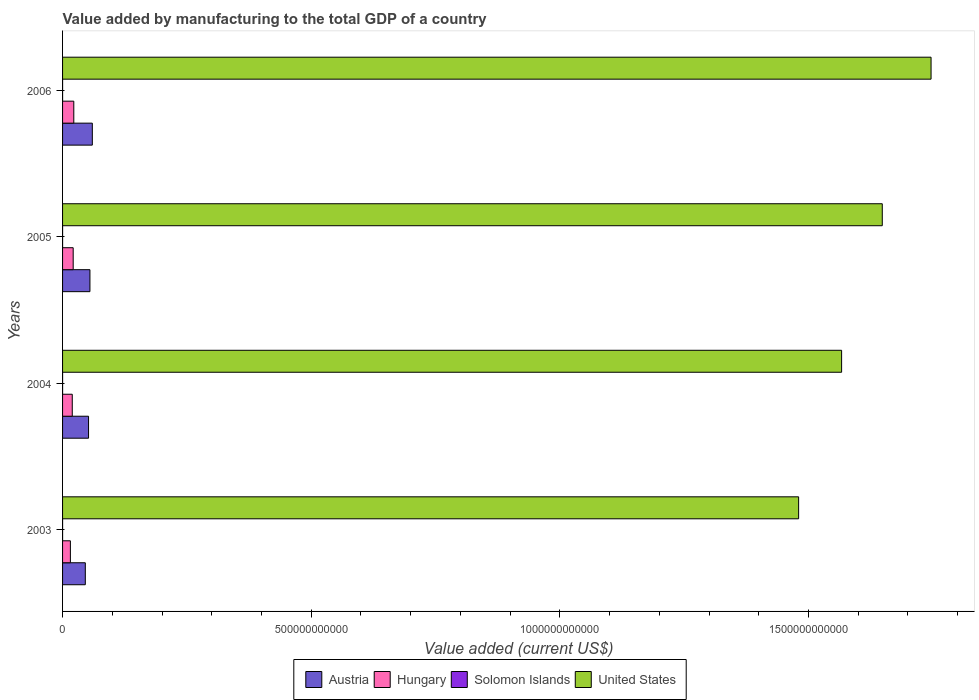How many different coloured bars are there?
Your answer should be very brief. 4. Are the number of bars on each tick of the Y-axis equal?
Offer a very short reply. Yes. How many bars are there on the 2nd tick from the bottom?
Make the answer very short. 4. What is the label of the 3rd group of bars from the top?
Your answer should be compact. 2004. In how many cases, is the number of bars for a given year not equal to the number of legend labels?
Your answer should be compact. 0. What is the value added by manufacturing to the total GDP in Austria in 2004?
Provide a short and direct response. 5.22e+1. Across all years, what is the maximum value added by manufacturing to the total GDP in Hungary?
Ensure brevity in your answer.  2.26e+1. Across all years, what is the minimum value added by manufacturing to the total GDP in Austria?
Your response must be concise. 4.57e+1. In which year was the value added by manufacturing to the total GDP in Hungary maximum?
Your response must be concise. 2006. In which year was the value added by manufacturing to the total GDP in Austria minimum?
Provide a succinct answer. 2003. What is the total value added by manufacturing to the total GDP in Solomon Islands in the graph?
Your answer should be compact. 8.92e+07. What is the difference between the value added by manufacturing to the total GDP in Hungary in 2003 and that in 2005?
Your answer should be compact. -5.61e+09. What is the difference between the value added by manufacturing to the total GDP in Solomon Islands in 2006 and the value added by manufacturing to the total GDP in Austria in 2005?
Offer a terse response. -5.50e+1. What is the average value added by manufacturing to the total GDP in Hungary per year?
Provide a short and direct response. 1.98e+1. In the year 2003, what is the difference between the value added by manufacturing to the total GDP in Hungary and value added by manufacturing to the total GDP in United States?
Keep it short and to the point. -1.46e+12. In how many years, is the value added by manufacturing to the total GDP in Austria greater than 200000000000 US$?
Give a very brief answer. 0. What is the ratio of the value added by manufacturing to the total GDP in United States in 2005 to that in 2006?
Make the answer very short. 0.94. Is the value added by manufacturing to the total GDP in Austria in 2003 less than that in 2006?
Ensure brevity in your answer.  Yes. What is the difference between the highest and the second highest value added by manufacturing to the total GDP in Hungary?
Your answer should be compact. 1.24e+09. What is the difference between the highest and the lowest value added by manufacturing to the total GDP in United States?
Ensure brevity in your answer.  2.66e+11. What does the 2nd bar from the top in 2004 represents?
Provide a succinct answer. Solomon Islands. What does the 2nd bar from the bottom in 2003 represents?
Give a very brief answer. Hungary. Is it the case that in every year, the sum of the value added by manufacturing to the total GDP in Austria and value added by manufacturing to the total GDP in Hungary is greater than the value added by manufacturing to the total GDP in United States?
Your response must be concise. No. What is the difference between two consecutive major ticks on the X-axis?
Keep it short and to the point. 5.00e+11. Does the graph contain grids?
Keep it short and to the point. No. How many legend labels are there?
Ensure brevity in your answer.  4. What is the title of the graph?
Ensure brevity in your answer.  Value added by manufacturing to the total GDP of a country. Does "Croatia" appear as one of the legend labels in the graph?
Make the answer very short. No. What is the label or title of the X-axis?
Provide a succinct answer. Value added (current US$). What is the label or title of the Y-axis?
Provide a succinct answer. Years. What is the Value added (current US$) in Austria in 2003?
Offer a very short reply. 4.57e+1. What is the Value added (current US$) of Hungary in 2003?
Make the answer very short. 1.57e+1. What is the Value added (current US$) in Solomon Islands in 2003?
Give a very brief answer. 2.09e+07. What is the Value added (current US$) of United States in 2003?
Offer a very short reply. 1.48e+12. What is the Value added (current US$) of Austria in 2004?
Your response must be concise. 5.22e+1. What is the Value added (current US$) of Hungary in 2004?
Your answer should be compact. 1.95e+1. What is the Value added (current US$) of Solomon Islands in 2004?
Offer a terse response. 2.35e+07. What is the Value added (current US$) in United States in 2004?
Offer a very short reply. 1.57e+12. What is the Value added (current US$) in Austria in 2005?
Provide a short and direct response. 5.50e+1. What is the Value added (current US$) in Hungary in 2005?
Ensure brevity in your answer.  2.14e+1. What is the Value added (current US$) in Solomon Islands in 2005?
Provide a short and direct response. 2.30e+07. What is the Value added (current US$) in United States in 2005?
Offer a terse response. 1.65e+12. What is the Value added (current US$) of Austria in 2006?
Offer a very short reply. 5.98e+1. What is the Value added (current US$) of Hungary in 2006?
Make the answer very short. 2.26e+1. What is the Value added (current US$) of Solomon Islands in 2006?
Make the answer very short. 2.17e+07. What is the Value added (current US$) of United States in 2006?
Make the answer very short. 1.75e+12. Across all years, what is the maximum Value added (current US$) of Austria?
Provide a short and direct response. 5.98e+1. Across all years, what is the maximum Value added (current US$) of Hungary?
Provide a succinct answer. 2.26e+1. Across all years, what is the maximum Value added (current US$) of Solomon Islands?
Provide a short and direct response. 2.35e+07. Across all years, what is the maximum Value added (current US$) of United States?
Offer a very short reply. 1.75e+12. Across all years, what is the minimum Value added (current US$) of Austria?
Offer a terse response. 4.57e+1. Across all years, what is the minimum Value added (current US$) of Hungary?
Provide a short and direct response. 1.57e+1. Across all years, what is the minimum Value added (current US$) of Solomon Islands?
Your response must be concise. 2.09e+07. Across all years, what is the minimum Value added (current US$) in United States?
Offer a terse response. 1.48e+12. What is the total Value added (current US$) in Austria in the graph?
Provide a succinct answer. 2.13e+11. What is the total Value added (current US$) of Hungary in the graph?
Offer a terse response. 7.92e+1. What is the total Value added (current US$) in Solomon Islands in the graph?
Your answer should be compact. 8.92e+07. What is the total Value added (current US$) in United States in the graph?
Your answer should be compact. 6.44e+12. What is the difference between the Value added (current US$) in Austria in 2003 and that in 2004?
Your answer should be compact. -6.50e+09. What is the difference between the Value added (current US$) of Hungary in 2003 and that in 2004?
Provide a short and direct response. -3.76e+09. What is the difference between the Value added (current US$) in Solomon Islands in 2003 and that in 2004?
Ensure brevity in your answer.  -2.68e+06. What is the difference between the Value added (current US$) in United States in 2003 and that in 2004?
Make the answer very short. -8.64e+1. What is the difference between the Value added (current US$) of Austria in 2003 and that in 2005?
Ensure brevity in your answer.  -9.31e+09. What is the difference between the Value added (current US$) of Hungary in 2003 and that in 2005?
Make the answer very short. -5.61e+09. What is the difference between the Value added (current US$) in Solomon Islands in 2003 and that in 2005?
Your response must be concise. -2.18e+06. What is the difference between the Value added (current US$) of United States in 2003 and that in 2005?
Keep it short and to the point. -1.68e+11. What is the difference between the Value added (current US$) of Austria in 2003 and that in 2006?
Your answer should be compact. -1.41e+1. What is the difference between the Value added (current US$) in Hungary in 2003 and that in 2006?
Ensure brevity in your answer.  -6.85e+09. What is the difference between the Value added (current US$) of Solomon Islands in 2003 and that in 2006?
Your answer should be compact. -8.86e+05. What is the difference between the Value added (current US$) in United States in 2003 and that in 2006?
Your answer should be very brief. -2.66e+11. What is the difference between the Value added (current US$) in Austria in 2004 and that in 2005?
Keep it short and to the point. -2.80e+09. What is the difference between the Value added (current US$) of Hungary in 2004 and that in 2005?
Give a very brief answer. -1.85e+09. What is the difference between the Value added (current US$) of Solomon Islands in 2004 and that in 2005?
Your answer should be very brief. 5.00e+05. What is the difference between the Value added (current US$) of United States in 2004 and that in 2005?
Offer a very short reply. -8.18e+1. What is the difference between the Value added (current US$) in Austria in 2004 and that in 2006?
Your response must be concise. -7.60e+09. What is the difference between the Value added (current US$) of Hungary in 2004 and that in 2006?
Your response must be concise. -3.09e+09. What is the difference between the Value added (current US$) of Solomon Islands in 2004 and that in 2006?
Make the answer very short. 1.79e+06. What is the difference between the Value added (current US$) in United States in 2004 and that in 2006?
Make the answer very short. -1.80e+11. What is the difference between the Value added (current US$) of Austria in 2005 and that in 2006?
Your answer should be very brief. -4.80e+09. What is the difference between the Value added (current US$) in Hungary in 2005 and that in 2006?
Offer a very short reply. -1.24e+09. What is the difference between the Value added (current US$) in Solomon Islands in 2005 and that in 2006?
Offer a terse response. 1.29e+06. What is the difference between the Value added (current US$) in United States in 2005 and that in 2006?
Provide a short and direct response. -9.81e+1. What is the difference between the Value added (current US$) in Austria in 2003 and the Value added (current US$) in Hungary in 2004?
Give a very brief answer. 2.62e+1. What is the difference between the Value added (current US$) of Austria in 2003 and the Value added (current US$) of Solomon Islands in 2004?
Make the answer very short. 4.57e+1. What is the difference between the Value added (current US$) in Austria in 2003 and the Value added (current US$) in United States in 2004?
Provide a short and direct response. -1.52e+12. What is the difference between the Value added (current US$) in Hungary in 2003 and the Value added (current US$) in Solomon Islands in 2004?
Provide a short and direct response. 1.57e+1. What is the difference between the Value added (current US$) of Hungary in 2003 and the Value added (current US$) of United States in 2004?
Provide a succinct answer. -1.55e+12. What is the difference between the Value added (current US$) of Solomon Islands in 2003 and the Value added (current US$) of United States in 2004?
Your answer should be compact. -1.57e+12. What is the difference between the Value added (current US$) in Austria in 2003 and the Value added (current US$) in Hungary in 2005?
Your answer should be very brief. 2.44e+1. What is the difference between the Value added (current US$) of Austria in 2003 and the Value added (current US$) of Solomon Islands in 2005?
Give a very brief answer. 4.57e+1. What is the difference between the Value added (current US$) in Austria in 2003 and the Value added (current US$) in United States in 2005?
Your answer should be very brief. -1.60e+12. What is the difference between the Value added (current US$) in Hungary in 2003 and the Value added (current US$) in Solomon Islands in 2005?
Provide a succinct answer. 1.57e+1. What is the difference between the Value added (current US$) in Hungary in 2003 and the Value added (current US$) in United States in 2005?
Make the answer very short. -1.63e+12. What is the difference between the Value added (current US$) of Solomon Islands in 2003 and the Value added (current US$) of United States in 2005?
Offer a terse response. -1.65e+12. What is the difference between the Value added (current US$) in Austria in 2003 and the Value added (current US$) in Hungary in 2006?
Ensure brevity in your answer.  2.31e+1. What is the difference between the Value added (current US$) in Austria in 2003 and the Value added (current US$) in Solomon Islands in 2006?
Offer a very short reply. 4.57e+1. What is the difference between the Value added (current US$) in Austria in 2003 and the Value added (current US$) in United States in 2006?
Keep it short and to the point. -1.70e+12. What is the difference between the Value added (current US$) in Hungary in 2003 and the Value added (current US$) in Solomon Islands in 2006?
Provide a succinct answer. 1.57e+1. What is the difference between the Value added (current US$) in Hungary in 2003 and the Value added (current US$) in United States in 2006?
Ensure brevity in your answer.  -1.73e+12. What is the difference between the Value added (current US$) of Solomon Islands in 2003 and the Value added (current US$) of United States in 2006?
Keep it short and to the point. -1.75e+12. What is the difference between the Value added (current US$) in Austria in 2004 and the Value added (current US$) in Hungary in 2005?
Provide a succinct answer. 3.09e+1. What is the difference between the Value added (current US$) of Austria in 2004 and the Value added (current US$) of Solomon Islands in 2005?
Offer a very short reply. 5.22e+1. What is the difference between the Value added (current US$) of Austria in 2004 and the Value added (current US$) of United States in 2005?
Offer a very short reply. -1.60e+12. What is the difference between the Value added (current US$) in Hungary in 2004 and the Value added (current US$) in Solomon Islands in 2005?
Offer a terse response. 1.95e+1. What is the difference between the Value added (current US$) of Hungary in 2004 and the Value added (current US$) of United States in 2005?
Provide a succinct answer. -1.63e+12. What is the difference between the Value added (current US$) of Solomon Islands in 2004 and the Value added (current US$) of United States in 2005?
Keep it short and to the point. -1.65e+12. What is the difference between the Value added (current US$) in Austria in 2004 and the Value added (current US$) in Hungary in 2006?
Make the answer very short. 2.96e+1. What is the difference between the Value added (current US$) in Austria in 2004 and the Value added (current US$) in Solomon Islands in 2006?
Your response must be concise. 5.22e+1. What is the difference between the Value added (current US$) in Austria in 2004 and the Value added (current US$) in United States in 2006?
Offer a terse response. -1.69e+12. What is the difference between the Value added (current US$) of Hungary in 2004 and the Value added (current US$) of Solomon Islands in 2006?
Ensure brevity in your answer.  1.95e+1. What is the difference between the Value added (current US$) in Hungary in 2004 and the Value added (current US$) in United States in 2006?
Provide a succinct answer. -1.73e+12. What is the difference between the Value added (current US$) of Solomon Islands in 2004 and the Value added (current US$) of United States in 2006?
Provide a succinct answer. -1.75e+12. What is the difference between the Value added (current US$) of Austria in 2005 and the Value added (current US$) of Hungary in 2006?
Keep it short and to the point. 3.24e+1. What is the difference between the Value added (current US$) in Austria in 2005 and the Value added (current US$) in Solomon Islands in 2006?
Offer a terse response. 5.50e+1. What is the difference between the Value added (current US$) in Austria in 2005 and the Value added (current US$) in United States in 2006?
Ensure brevity in your answer.  -1.69e+12. What is the difference between the Value added (current US$) in Hungary in 2005 and the Value added (current US$) in Solomon Islands in 2006?
Give a very brief answer. 2.13e+1. What is the difference between the Value added (current US$) in Hungary in 2005 and the Value added (current US$) in United States in 2006?
Your answer should be compact. -1.73e+12. What is the difference between the Value added (current US$) of Solomon Islands in 2005 and the Value added (current US$) of United States in 2006?
Make the answer very short. -1.75e+12. What is the average Value added (current US$) of Austria per year?
Keep it short and to the point. 5.32e+1. What is the average Value added (current US$) of Hungary per year?
Give a very brief answer. 1.98e+1. What is the average Value added (current US$) in Solomon Islands per year?
Keep it short and to the point. 2.23e+07. What is the average Value added (current US$) of United States per year?
Give a very brief answer. 1.61e+12. In the year 2003, what is the difference between the Value added (current US$) of Austria and Value added (current US$) of Hungary?
Make the answer very short. 3.00e+1. In the year 2003, what is the difference between the Value added (current US$) in Austria and Value added (current US$) in Solomon Islands?
Give a very brief answer. 4.57e+1. In the year 2003, what is the difference between the Value added (current US$) in Austria and Value added (current US$) in United States?
Offer a terse response. -1.43e+12. In the year 2003, what is the difference between the Value added (current US$) in Hungary and Value added (current US$) in Solomon Islands?
Provide a succinct answer. 1.57e+1. In the year 2003, what is the difference between the Value added (current US$) in Hungary and Value added (current US$) in United States?
Your response must be concise. -1.46e+12. In the year 2003, what is the difference between the Value added (current US$) of Solomon Islands and Value added (current US$) of United States?
Offer a terse response. -1.48e+12. In the year 2004, what is the difference between the Value added (current US$) in Austria and Value added (current US$) in Hungary?
Provide a succinct answer. 3.27e+1. In the year 2004, what is the difference between the Value added (current US$) of Austria and Value added (current US$) of Solomon Islands?
Provide a short and direct response. 5.22e+1. In the year 2004, what is the difference between the Value added (current US$) of Austria and Value added (current US$) of United States?
Offer a terse response. -1.51e+12. In the year 2004, what is the difference between the Value added (current US$) of Hungary and Value added (current US$) of Solomon Islands?
Give a very brief answer. 1.95e+1. In the year 2004, what is the difference between the Value added (current US$) in Hungary and Value added (current US$) in United States?
Your answer should be compact. -1.55e+12. In the year 2004, what is the difference between the Value added (current US$) in Solomon Islands and Value added (current US$) in United States?
Make the answer very short. -1.57e+12. In the year 2005, what is the difference between the Value added (current US$) in Austria and Value added (current US$) in Hungary?
Your answer should be very brief. 3.37e+1. In the year 2005, what is the difference between the Value added (current US$) of Austria and Value added (current US$) of Solomon Islands?
Provide a succinct answer. 5.50e+1. In the year 2005, what is the difference between the Value added (current US$) of Austria and Value added (current US$) of United States?
Offer a terse response. -1.59e+12. In the year 2005, what is the difference between the Value added (current US$) of Hungary and Value added (current US$) of Solomon Islands?
Ensure brevity in your answer.  2.13e+1. In the year 2005, what is the difference between the Value added (current US$) in Hungary and Value added (current US$) in United States?
Offer a very short reply. -1.63e+12. In the year 2005, what is the difference between the Value added (current US$) in Solomon Islands and Value added (current US$) in United States?
Offer a very short reply. -1.65e+12. In the year 2006, what is the difference between the Value added (current US$) in Austria and Value added (current US$) in Hungary?
Your answer should be very brief. 3.72e+1. In the year 2006, what is the difference between the Value added (current US$) in Austria and Value added (current US$) in Solomon Islands?
Keep it short and to the point. 5.98e+1. In the year 2006, what is the difference between the Value added (current US$) of Austria and Value added (current US$) of United States?
Offer a terse response. -1.69e+12. In the year 2006, what is the difference between the Value added (current US$) in Hungary and Value added (current US$) in Solomon Islands?
Provide a short and direct response. 2.26e+1. In the year 2006, what is the difference between the Value added (current US$) of Hungary and Value added (current US$) of United States?
Your answer should be very brief. -1.72e+12. In the year 2006, what is the difference between the Value added (current US$) in Solomon Islands and Value added (current US$) in United States?
Offer a terse response. -1.75e+12. What is the ratio of the Value added (current US$) in Austria in 2003 to that in 2004?
Give a very brief answer. 0.88. What is the ratio of the Value added (current US$) of Hungary in 2003 to that in 2004?
Ensure brevity in your answer.  0.81. What is the ratio of the Value added (current US$) of Solomon Islands in 2003 to that in 2004?
Provide a short and direct response. 0.89. What is the ratio of the Value added (current US$) of United States in 2003 to that in 2004?
Offer a terse response. 0.94. What is the ratio of the Value added (current US$) in Austria in 2003 to that in 2005?
Your answer should be compact. 0.83. What is the ratio of the Value added (current US$) of Hungary in 2003 to that in 2005?
Ensure brevity in your answer.  0.74. What is the ratio of the Value added (current US$) of Solomon Islands in 2003 to that in 2005?
Provide a short and direct response. 0.91. What is the ratio of the Value added (current US$) in United States in 2003 to that in 2005?
Keep it short and to the point. 0.9. What is the ratio of the Value added (current US$) in Austria in 2003 to that in 2006?
Ensure brevity in your answer.  0.76. What is the ratio of the Value added (current US$) in Hungary in 2003 to that in 2006?
Give a very brief answer. 0.7. What is the ratio of the Value added (current US$) of Solomon Islands in 2003 to that in 2006?
Your response must be concise. 0.96. What is the ratio of the Value added (current US$) of United States in 2003 to that in 2006?
Offer a very short reply. 0.85. What is the ratio of the Value added (current US$) in Austria in 2004 to that in 2005?
Your answer should be very brief. 0.95. What is the ratio of the Value added (current US$) in Hungary in 2004 to that in 2005?
Make the answer very short. 0.91. What is the ratio of the Value added (current US$) of Solomon Islands in 2004 to that in 2005?
Ensure brevity in your answer.  1.02. What is the ratio of the Value added (current US$) in United States in 2004 to that in 2005?
Ensure brevity in your answer.  0.95. What is the ratio of the Value added (current US$) of Austria in 2004 to that in 2006?
Your response must be concise. 0.87. What is the ratio of the Value added (current US$) of Hungary in 2004 to that in 2006?
Your response must be concise. 0.86. What is the ratio of the Value added (current US$) in Solomon Islands in 2004 to that in 2006?
Ensure brevity in your answer.  1.08. What is the ratio of the Value added (current US$) in United States in 2004 to that in 2006?
Give a very brief answer. 0.9. What is the ratio of the Value added (current US$) of Austria in 2005 to that in 2006?
Offer a terse response. 0.92. What is the ratio of the Value added (current US$) in Hungary in 2005 to that in 2006?
Offer a very short reply. 0.94. What is the ratio of the Value added (current US$) in Solomon Islands in 2005 to that in 2006?
Your response must be concise. 1.06. What is the ratio of the Value added (current US$) in United States in 2005 to that in 2006?
Your response must be concise. 0.94. What is the difference between the highest and the second highest Value added (current US$) of Austria?
Your answer should be compact. 4.80e+09. What is the difference between the highest and the second highest Value added (current US$) of Hungary?
Your response must be concise. 1.24e+09. What is the difference between the highest and the second highest Value added (current US$) of Solomon Islands?
Offer a terse response. 5.00e+05. What is the difference between the highest and the second highest Value added (current US$) of United States?
Offer a very short reply. 9.81e+1. What is the difference between the highest and the lowest Value added (current US$) of Austria?
Keep it short and to the point. 1.41e+1. What is the difference between the highest and the lowest Value added (current US$) of Hungary?
Offer a terse response. 6.85e+09. What is the difference between the highest and the lowest Value added (current US$) of Solomon Islands?
Your response must be concise. 2.68e+06. What is the difference between the highest and the lowest Value added (current US$) of United States?
Give a very brief answer. 2.66e+11. 